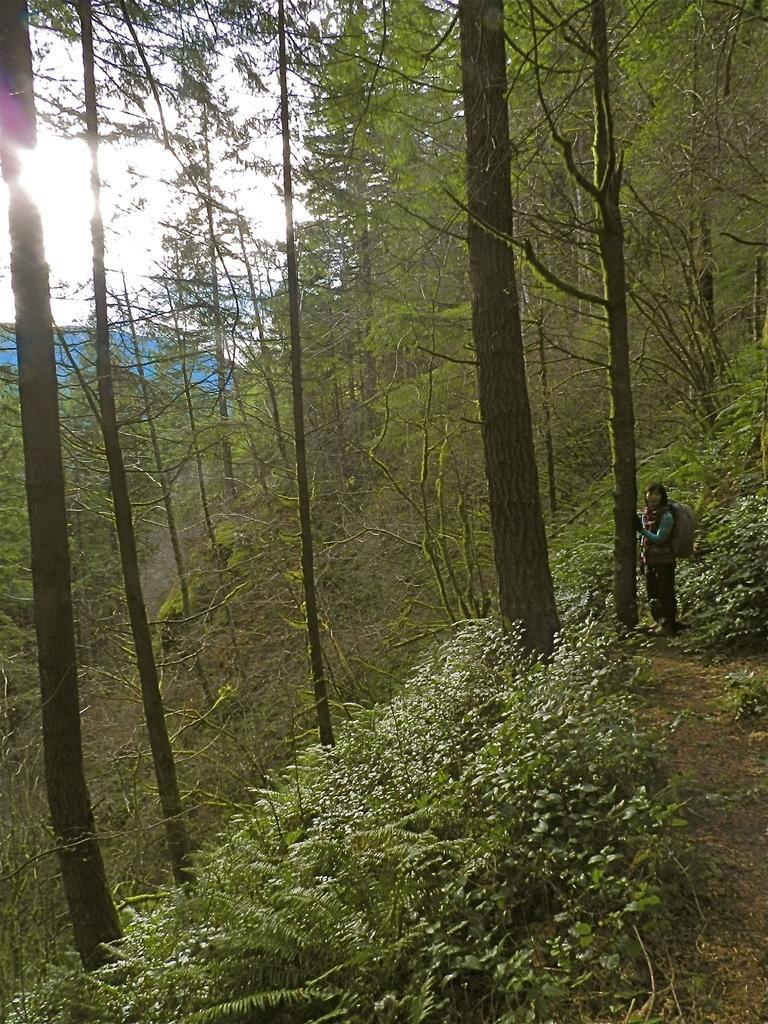Describe this image in one or two sentences. At the bottom of the picture, we see the trees. On the right side, we see a woman who is wearing the backpack is standing. There are trees in the background. In the background, we see the sky, the sun and a blue color sheet. It might be a tent. 